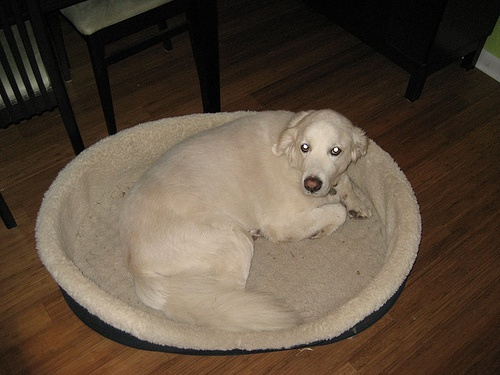Describe the objects in this image and their specific colors. I can see bed in black, gray, and tan tones, dog in black, tan, and gray tones, and chair in black, darkgreen, and gray tones in this image. 